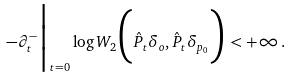<formula> <loc_0><loc_0><loc_500><loc_500>- \partial _ { t } ^ { - } \Big | _ { t = 0 } \log W _ { 2 } \Big ( \hat { P } _ { t } \delta _ { o } , \hat { P } _ { t } \delta _ { p _ { 0 } } \Big ) < + \infty \, .</formula> 